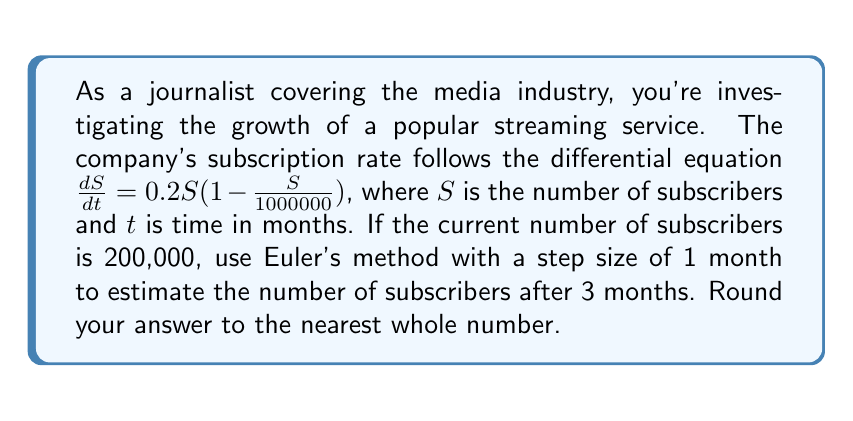Can you answer this question? To solve this problem using Euler's method, we'll follow these steps:

1) Euler's method is given by the formula:
   $$S_{n+1} = S_n + h \cdot f(t_n, S_n)$$
   where $h$ is the step size, and $f(t, S) = \frac{dS}{dt}$

2) In this case, $f(t, S) = 0.2S(1 - \frac{S}{1000000})$

3) We're given:
   - Initial subscribers $S_0 = 200,000$
   - Step size $h = 1$ month
   - We need to calculate for 3 months

4) Let's calculate step by step:

   For $n = 0$ (after 1 month):
   $$S_1 = 200000 + 1 \cdot 0.2 \cdot 200000(1 - \frac{200000}{1000000}) = 232000$$

   For $n = 1$ (after 2 months):
   $$S_2 = 232000 + 1 \cdot 0.2 \cdot 232000(1 - \frac{232000}{1000000}) = 265856$$

   For $n = 2$ (after 3 months):
   $$S_3 = 265856 + 1 \cdot 0.2 \cdot 265856(1 - \frac{265856}{1000000}) = 300355.8144$$

5) Rounding to the nearest whole number, we get 300,356 subscribers after 3 months.
Answer: 300,356 subscribers 